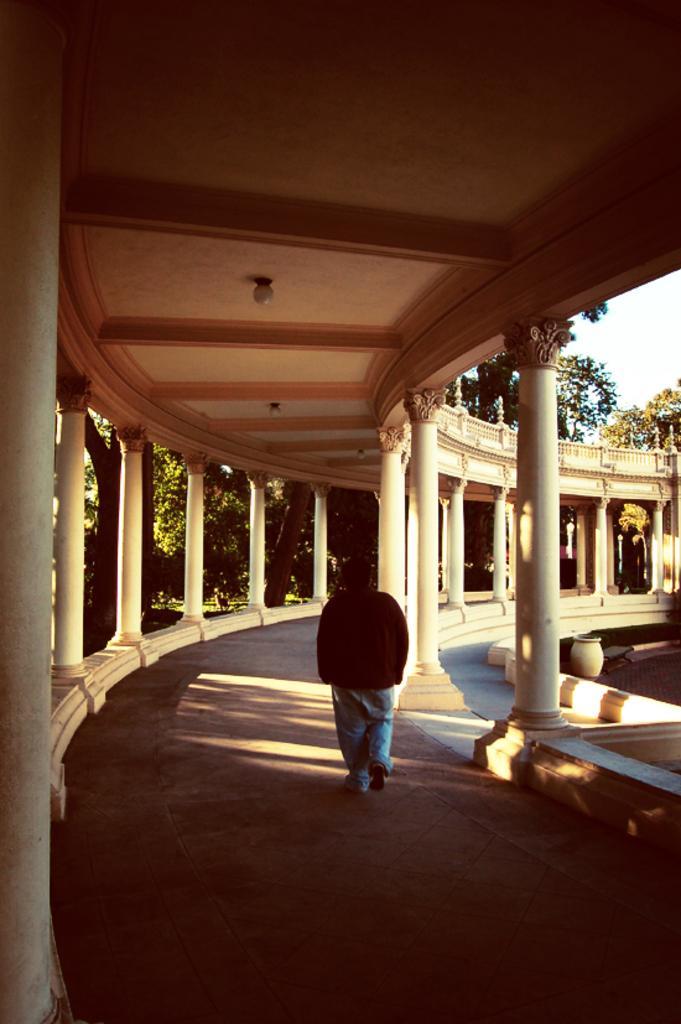Please provide a concise description of this image. In the center of the image we can see a man is walking. In the background of the image we can see the pillars, roof, lights, trees, pot. On the right side of the image we can see the sky. At the bottom of the image we can see the floor. 